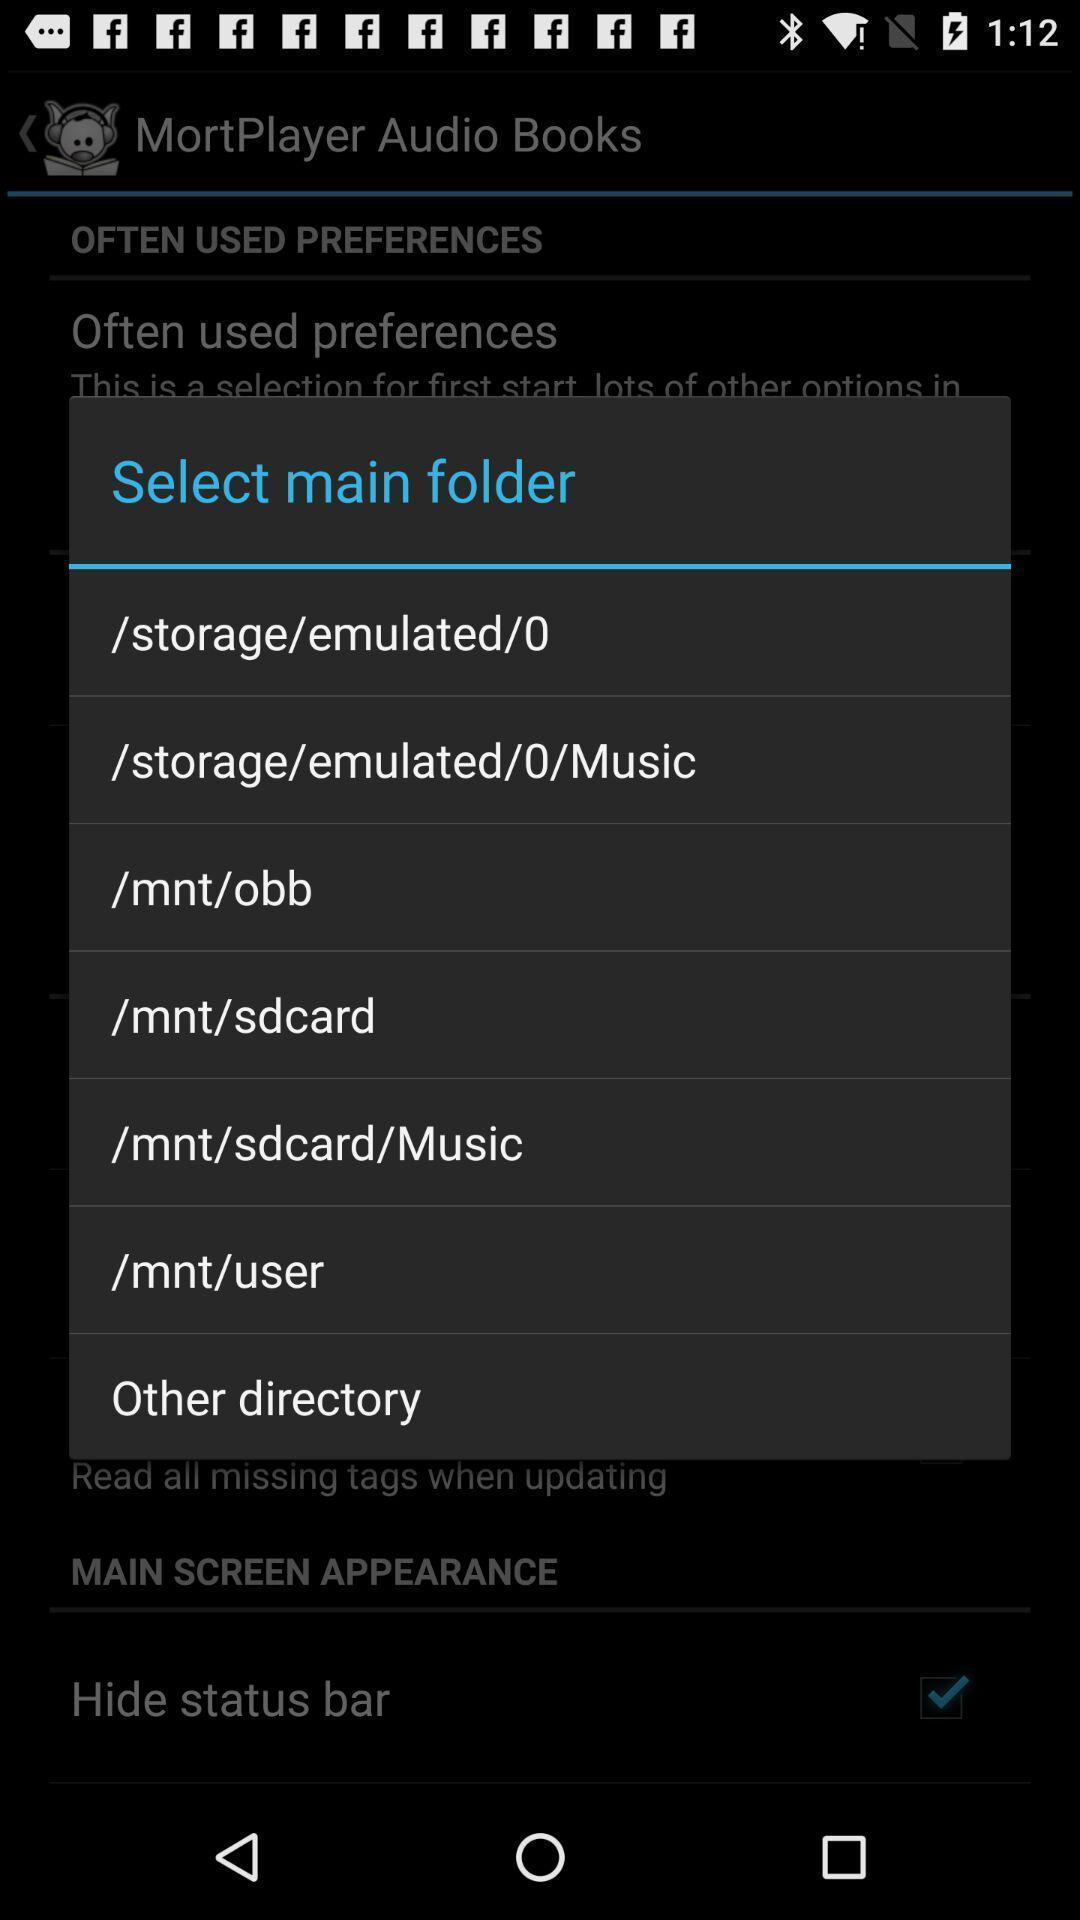Provide a textual representation of this image. Pop-up showing list of various folders. 